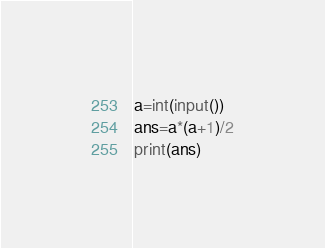Convert code to text. <code><loc_0><loc_0><loc_500><loc_500><_Python_>a=int(input())
ans=a*(a+1)/2
print(ans)
</code> 